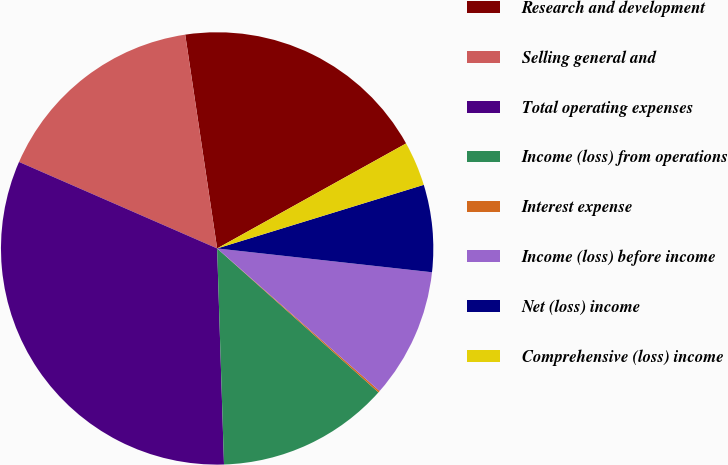<chart> <loc_0><loc_0><loc_500><loc_500><pie_chart><fcel>Research and development<fcel>Selling general and<fcel>Total operating expenses<fcel>Income (loss) from operations<fcel>Interest expense<fcel>Income (loss) before income<fcel>Net (loss) income<fcel>Comprehensive (loss) income<nl><fcel>19.29%<fcel>16.09%<fcel>32.06%<fcel>12.9%<fcel>0.13%<fcel>9.71%<fcel>6.51%<fcel>3.32%<nl></chart> 